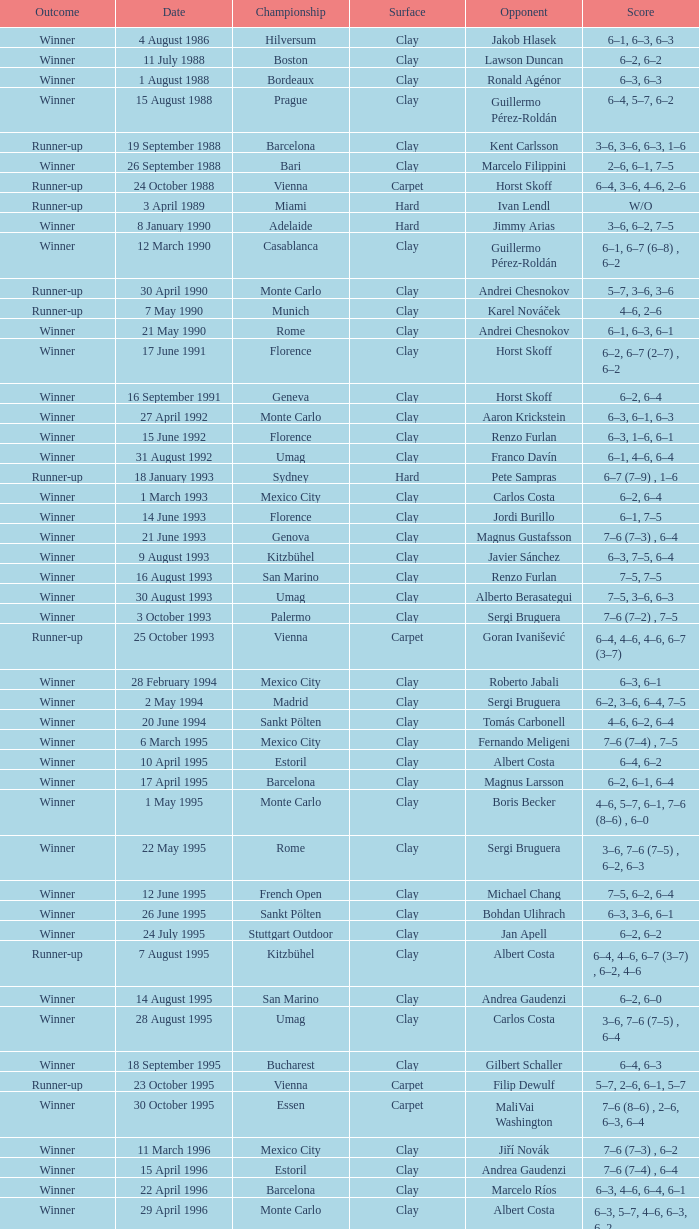Who is the opponent when the surface is clay, the outcome is winner and the championship is estoril on 15 april 1996? Andrea Gaudenzi. 